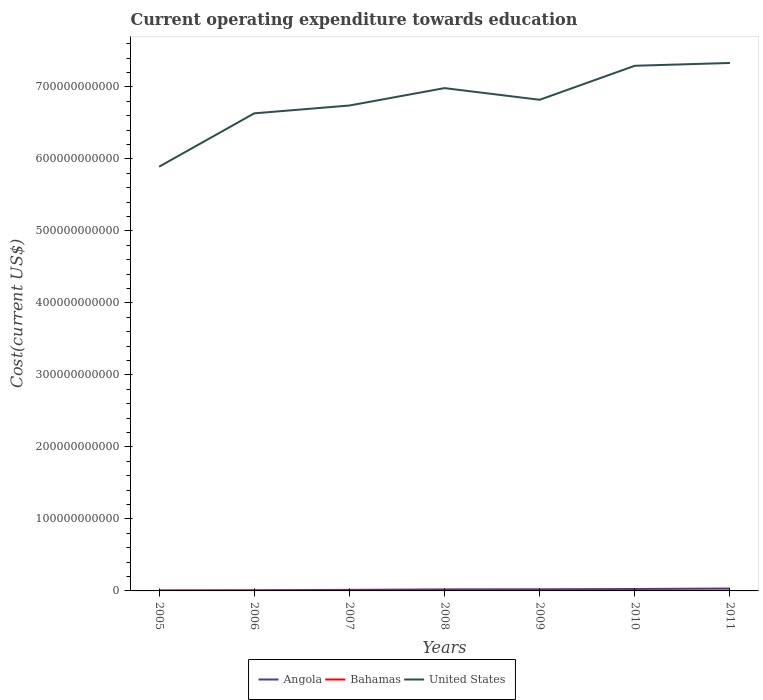How many different coloured lines are there?
Give a very brief answer. 3. Does the line corresponding to Angola intersect with the line corresponding to United States?
Provide a succinct answer. No. Is the number of lines equal to the number of legend labels?
Provide a succinct answer. Yes. Across all years, what is the maximum expenditure towards education in Angola?
Provide a short and direct response. 6.26e+08. What is the total expenditure towards education in United States in the graph?
Keep it short and to the point. -9.29e+1. What is the difference between the highest and the second highest expenditure towards education in United States?
Your response must be concise. 1.44e+11. Is the expenditure towards education in United States strictly greater than the expenditure towards education in Angola over the years?
Give a very brief answer. No. What is the difference between two consecutive major ticks on the Y-axis?
Ensure brevity in your answer.  1.00e+11. Are the values on the major ticks of Y-axis written in scientific E-notation?
Offer a terse response. No. Does the graph contain grids?
Make the answer very short. No. How many legend labels are there?
Give a very brief answer. 3. What is the title of the graph?
Offer a terse response. Current operating expenditure towards education. What is the label or title of the X-axis?
Your response must be concise. Years. What is the label or title of the Y-axis?
Your answer should be compact. Cost(current US$). What is the Cost(current US$) of Angola in 2005?
Keep it short and to the point. 6.26e+08. What is the Cost(current US$) in Bahamas in 2005?
Provide a succinct answer. 2.89e+08. What is the Cost(current US$) of United States in 2005?
Provide a succinct answer. 5.89e+11. What is the Cost(current US$) of Angola in 2006?
Keep it short and to the point. 8.86e+08. What is the Cost(current US$) in Bahamas in 2006?
Your answer should be compact. 2.97e+08. What is the Cost(current US$) in United States in 2006?
Offer a very short reply. 6.63e+11. What is the Cost(current US$) of Angola in 2007?
Your response must be concise. 1.46e+09. What is the Cost(current US$) in Bahamas in 2007?
Your response must be concise. 3.10e+08. What is the Cost(current US$) of United States in 2007?
Ensure brevity in your answer.  6.74e+11. What is the Cost(current US$) in Angola in 2008?
Keep it short and to the point. 2.14e+09. What is the Cost(current US$) in Bahamas in 2008?
Your answer should be compact. 3.13e+08. What is the Cost(current US$) of United States in 2008?
Your answer should be very brief. 6.98e+11. What is the Cost(current US$) in Angola in 2009?
Your response must be concise. 2.27e+09. What is the Cost(current US$) of Bahamas in 2009?
Give a very brief answer. 2.94e+08. What is the Cost(current US$) in United States in 2009?
Your response must be concise. 6.82e+11. What is the Cost(current US$) of Angola in 2010?
Your answer should be compact. 2.66e+09. What is the Cost(current US$) of Bahamas in 2010?
Offer a terse response. 2.94e+08. What is the Cost(current US$) of United States in 2010?
Your answer should be very brief. 7.29e+11. What is the Cost(current US$) of Angola in 2011?
Make the answer very short. 3.35e+09. What is the Cost(current US$) in Bahamas in 2011?
Keep it short and to the point. 2.94e+08. What is the Cost(current US$) in United States in 2011?
Offer a very short reply. 7.33e+11. Across all years, what is the maximum Cost(current US$) of Angola?
Provide a succinct answer. 3.35e+09. Across all years, what is the maximum Cost(current US$) in Bahamas?
Your response must be concise. 3.13e+08. Across all years, what is the maximum Cost(current US$) in United States?
Ensure brevity in your answer.  7.33e+11. Across all years, what is the minimum Cost(current US$) in Angola?
Provide a succinct answer. 6.26e+08. Across all years, what is the minimum Cost(current US$) in Bahamas?
Keep it short and to the point. 2.89e+08. Across all years, what is the minimum Cost(current US$) of United States?
Your answer should be very brief. 5.89e+11. What is the total Cost(current US$) in Angola in the graph?
Your response must be concise. 1.34e+1. What is the total Cost(current US$) of Bahamas in the graph?
Provide a succinct answer. 2.09e+09. What is the total Cost(current US$) of United States in the graph?
Your response must be concise. 4.77e+12. What is the difference between the Cost(current US$) of Angola in 2005 and that in 2006?
Keep it short and to the point. -2.60e+08. What is the difference between the Cost(current US$) in Bahamas in 2005 and that in 2006?
Provide a short and direct response. -8.57e+06. What is the difference between the Cost(current US$) of United States in 2005 and that in 2006?
Make the answer very short. -7.41e+1. What is the difference between the Cost(current US$) in Angola in 2005 and that in 2007?
Offer a terse response. -8.34e+08. What is the difference between the Cost(current US$) of Bahamas in 2005 and that in 2007?
Give a very brief answer. -2.16e+07. What is the difference between the Cost(current US$) of United States in 2005 and that in 2007?
Make the answer very short. -8.50e+1. What is the difference between the Cost(current US$) in Angola in 2005 and that in 2008?
Keep it short and to the point. -1.52e+09. What is the difference between the Cost(current US$) in Bahamas in 2005 and that in 2008?
Ensure brevity in your answer.  -2.44e+07. What is the difference between the Cost(current US$) in United States in 2005 and that in 2008?
Offer a terse response. -1.09e+11. What is the difference between the Cost(current US$) of Angola in 2005 and that in 2009?
Ensure brevity in your answer.  -1.65e+09. What is the difference between the Cost(current US$) in Bahamas in 2005 and that in 2009?
Keep it short and to the point. -5.53e+06. What is the difference between the Cost(current US$) in United States in 2005 and that in 2009?
Keep it short and to the point. -9.29e+1. What is the difference between the Cost(current US$) in Angola in 2005 and that in 2010?
Provide a succinct answer. -2.04e+09. What is the difference between the Cost(current US$) in Bahamas in 2005 and that in 2010?
Your answer should be very brief. -5.77e+06. What is the difference between the Cost(current US$) of United States in 2005 and that in 2010?
Ensure brevity in your answer.  -1.40e+11. What is the difference between the Cost(current US$) in Angola in 2005 and that in 2011?
Make the answer very short. -2.72e+09. What is the difference between the Cost(current US$) in Bahamas in 2005 and that in 2011?
Offer a terse response. -4.97e+06. What is the difference between the Cost(current US$) of United States in 2005 and that in 2011?
Keep it short and to the point. -1.44e+11. What is the difference between the Cost(current US$) in Angola in 2006 and that in 2007?
Offer a very short reply. -5.75e+08. What is the difference between the Cost(current US$) in Bahamas in 2006 and that in 2007?
Offer a terse response. -1.30e+07. What is the difference between the Cost(current US$) of United States in 2006 and that in 2007?
Offer a terse response. -1.09e+1. What is the difference between the Cost(current US$) of Angola in 2006 and that in 2008?
Make the answer very short. -1.26e+09. What is the difference between the Cost(current US$) of Bahamas in 2006 and that in 2008?
Offer a very short reply. -1.59e+07. What is the difference between the Cost(current US$) of United States in 2006 and that in 2008?
Your response must be concise. -3.50e+1. What is the difference between the Cost(current US$) in Angola in 2006 and that in 2009?
Provide a succinct answer. -1.39e+09. What is the difference between the Cost(current US$) of Bahamas in 2006 and that in 2009?
Offer a very short reply. 3.04e+06. What is the difference between the Cost(current US$) in United States in 2006 and that in 2009?
Provide a short and direct response. -1.88e+1. What is the difference between the Cost(current US$) in Angola in 2006 and that in 2010?
Ensure brevity in your answer.  -1.78e+09. What is the difference between the Cost(current US$) in Bahamas in 2006 and that in 2010?
Provide a short and direct response. 2.80e+06. What is the difference between the Cost(current US$) of United States in 2006 and that in 2010?
Your response must be concise. -6.61e+1. What is the difference between the Cost(current US$) of Angola in 2006 and that in 2011?
Your answer should be compact. -2.46e+09. What is the difference between the Cost(current US$) in Bahamas in 2006 and that in 2011?
Give a very brief answer. 3.60e+06. What is the difference between the Cost(current US$) of United States in 2006 and that in 2011?
Your answer should be very brief. -7.00e+1. What is the difference between the Cost(current US$) of Angola in 2007 and that in 2008?
Ensure brevity in your answer.  -6.82e+08. What is the difference between the Cost(current US$) of Bahamas in 2007 and that in 2008?
Make the answer very short. -2.84e+06. What is the difference between the Cost(current US$) of United States in 2007 and that in 2008?
Your answer should be very brief. -2.42e+1. What is the difference between the Cost(current US$) in Angola in 2007 and that in 2009?
Give a very brief answer. -8.11e+08. What is the difference between the Cost(current US$) in Bahamas in 2007 and that in 2009?
Your answer should be very brief. 1.61e+07. What is the difference between the Cost(current US$) in United States in 2007 and that in 2009?
Ensure brevity in your answer.  -7.97e+09. What is the difference between the Cost(current US$) of Angola in 2007 and that in 2010?
Your answer should be compact. -1.20e+09. What is the difference between the Cost(current US$) in Bahamas in 2007 and that in 2010?
Your answer should be very brief. 1.58e+07. What is the difference between the Cost(current US$) of United States in 2007 and that in 2010?
Your answer should be very brief. -5.52e+1. What is the difference between the Cost(current US$) in Angola in 2007 and that in 2011?
Provide a succinct answer. -1.89e+09. What is the difference between the Cost(current US$) of Bahamas in 2007 and that in 2011?
Ensure brevity in your answer.  1.66e+07. What is the difference between the Cost(current US$) in United States in 2007 and that in 2011?
Your answer should be very brief. -5.91e+1. What is the difference between the Cost(current US$) in Angola in 2008 and that in 2009?
Make the answer very short. -1.28e+08. What is the difference between the Cost(current US$) in Bahamas in 2008 and that in 2009?
Keep it short and to the point. 1.89e+07. What is the difference between the Cost(current US$) in United States in 2008 and that in 2009?
Offer a terse response. 1.62e+1. What is the difference between the Cost(current US$) of Angola in 2008 and that in 2010?
Offer a terse response. -5.19e+08. What is the difference between the Cost(current US$) in Bahamas in 2008 and that in 2010?
Provide a short and direct response. 1.87e+07. What is the difference between the Cost(current US$) of United States in 2008 and that in 2010?
Offer a terse response. -3.10e+1. What is the difference between the Cost(current US$) of Angola in 2008 and that in 2011?
Offer a terse response. -1.21e+09. What is the difference between the Cost(current US$) in Bahamas in 2008 and that in 2011?
Ensure brevity in your answer.  1.95e+07. What is the difference between the Cost(current US$) of United States in 2008 and that in 2011?
Ensure brevity in your answer.  -3.49e+1. What is the difference between the Cost(current US$) of Angola in 2009 and that in 2010?
Keep it short and to the point. -3.91e+08. What is the difference between the Cost(current US$) of Bahamas in 2009 and that in 2010?
Ensure brevity in your answer.  -2.47e+05. What is the difference between the Cost(current US$) in United States in 2009 and that in 2010?
Give a very brief answer. -4.72e+1. What is the difference between the Cost(current US$) in Angola in 2009 and that in 2011?
Offer a terse response. -1.08e+09. What is the difference between the Cost(current US$) of Bahamas in 2009 and that in 2011?
Offer a very short reply. 5.57e+05. What is the difference between the Cost(current US$) of United States in 2009 and that in 2011?
Provide a short and direct response. -5.11e+1. What is the difference between the Cost(current US$) in Angola in 2010 and that in 2011?
Give a very brief answer. -6.88e+08. What is the difference between the Cost(current US$) in Bahamas in 2010 and that in 2011?
Provide a short and direct response. 8.04e+05. What is the difference between the Cost(current US$) in United States in 2010 and that in 2011?
Offer a very short reply. -3.88e+09. What is the difference between the Cost(current US$) in Angola in 2005 and the Cost(current US$) in Bahamas in 2006?
Provide a short and direct response. 3.29e+08. What is the difference between the Cost(current US$) of Angola in 2005 and the Cost(current US$) of United States in 2006?
Ensure brevity in your answer.  -6.63e+11. What is the difference between the Cost(current US$) in Bahamas in 2005 and the Cost(current US$) in United States in 2006?
Offer a very short reply. -6.63e+11. What is the difference between the Cost(current US$) in Angola in 2005 and the Cost(current US$) in Bahamas in 2007?
Offer a terse response. 3.16e+08. What is the difference between the Cost(current US$) of Angola in 2005 and the Cost(current US$) of United States in 2007?
Offer a very short reply. -6.73e+11. What is the difference between the Cost(current US$) in Bahamas in 2005 and the Cost(current US$) in United States in 2007?
Your answer should be very brief. -6.74e+11. What is the difference between the Cost(current US$) of Angola in 2005 and the Cost(current US$) of Bahamas in 2008?
Ensure brevity in your answer.  3.13e+08. What is the difference between the Cost(current US$) in Angola in 2005 and the Cost(current US$) in United States in 2008?
Your answer should be compact. -6.98e+11. What is the difference between the Cost(current US$) of Bahamas in 2005 and the Cost(current US$) of United States in 2008?
Give a very brief answer. -6.98e+11. What is the difference between the Cost(current US$) in Angola in 2005 and the Cost(current US$) in Bahamas in 2009?
Make the answer very short. 3.32e+08. What is the difference between the Cost(current US$) in Angola in 2005 and the Cost(current US$) in United States in 2009?
Make the answer very short. -6.81e+11. What is the difference between the Cost(current US$) of Bahamas in 2005 and the Cost(current US$) of United States in 2009?
Give a very brief answer. -6.82e+11. What is the difference between the Cost(current US$) of Angola in 2005 and the Cost(current US$) of Bahamas in 2010?
Provide a succinct answer. 3.32e+08. What is the difference between the Cost(current US$) in Angola in 2005 and the Cost(current US$) in United States in 2010?
Provide a short and direct response. -7.29e+11. What is the difference between the Cost(current US$) in Bahamas in 2005 and the Cost(current US$) in United States in 2010?
Provide a short and direct response. -7.29e+11. What is the difference between the Cost(current US$) in Angola in 2005 and the Cost(current US$) in Bahamas in 2011?
Ensure brevity in your answer.  3.32e+08. What is the difference between the Cost(current US$) of Angola in 2005 and the Cost(current US$) of United States in 2011?
Your answer should be compact. -7.33e+11. What is the difference between the Cost(current US$) in Bahamas in 2005 and the Cost(current US$) in United States in 2011?
Your answer should be compact. -7.33e+11. What is the difference between the Cost(current US$) in Angola in 2006 and the Cost(current US$) in Bahamas in 2007?
Provide a short and direct response. 5.75e+08. What is the difference between the Cost(current US$) of Angola in 2006 and the Cost(current US$) of United States in 2007?
Give a very brief answer. -6.73e+11. What is the difference between the Cost(current US$) in Bahamas in 2006 and the Cost(current US$) in United States in 2007?
Keep it short and to the point. -6.74e+11. What is the difference between the Cost(current US$) in Angola in 2006 and the Cost(current US$) in Bahamas in 2008?
Your response must be concise. 5.73e+08. What is the difference between the Cost(current US$) in Angola in 2006 and the Cost(current US$) in United States in 2008?
Give a very brief answer. -6.97e+11. What is the difference between the Cost(current US$) in Bahamas in 2006 and the Cost(current US$) in United States in 2008?
Keep it short and to the point. -6.98e+11. What is the difference between the Cost(current US$) of Angola in 2006 and the Cost(current US$) of Bahamas in 2009?
Give a very brief answer. 5.91e+08. What is the difference between the Cost(current US$) of Angola in 2006 and the Cost(current US$) of United States in 2009?
Make the answer very short. -6.81e+11. What is the difference between the Cost(current US$) of Bahamas in 2006 and the Cost(current US$) of United States in 2009?
Your response must be concise. -6.82e+11. What is the difference between the Cost(current US$) in Angola in 2006 and the Cost(current US$) in Bahamas in 2010?
Offer a very short reply. 5.91e+08. What is the difference between the Cost(current US$) of Angola in 2006 and the Cost(current US$) of United States in 2010?
Make the answer very short. -7.28e+11. What is the difference between the Cost(current US$) in Bahamas in 2006 and the Cost(current US$) in United States in 2010?
Offer a very short reply. -7.29e+11. What is the difference between the Cost(current US$) of Angola in 2006 and the Cost(current US$) of Bahamas in 2011?
Ensure brevity in your answer.  5.92e+08. What is the difference between the Cost(current US$) in Angola in 2006 and the Cost(current US$) in United States in 2011?
Make the answer very short. -7.32e+11. What is the difference between the Cost(current US$) of Bahamas in 2006 and the Cost(current US$) of United States in 2011?
Your answer should be compact. -7.33e+11. What is the difference between the Cost(current US$) in Angola in 2007 and the Cost(current US$) in Bahamas in 2008?
Provide a short and direct response. 1.15e+09. What is the difference between the Cost(current US$) of Angola in 2007 and the Cost(current US$) of United States in 2008?
Provide a succinct answer. -6.97e+11. What is the difference between the Cost(current US$) of Bahamas in 2007 and the Cost(current US$) of United States in 2008?
Give a very brief answer. -6.98e+11. What is the difference between the Cost(current US$) in Angola in 2007 and the Cost(current US$) in Bahamas in 2009?
Make the answer very short. 1.17e+09. What is the difference between the Cost(current US$) of Angola in 2007 and the Cost(current US$) of United States in 2009?
Make the answer very short. -6.81e+11. What is the difference between the Cost(current US$) of Bahamas in 2007 and the Cost(current US$) of United States in 2009?
Make the answer very short. -6.82e+11. What is the difference between the Cost(current US$) in Angola in 2007 and the Cost(current US$) in Bahamas in 2010?
Offer a very short reply. 1.17e+09. What is the difference between the Cost(current US$) in Angola in 2007 and the Cost(current US$) in United States in 2010?
Give a very brief answer. -7.28e+11. What is the difference between the Cost(current US$) of Bahamas in 2007 and the Cost(current US$) of United States in 2010?
Give a very brief answer. -7.29e+11. What is the difference between the Cost(current US$) of Angola in 2007 and the Cost(current US$) of Bahamas in 2011?
Make the answer very short. 1.17e+09. What is the difference between the Cost(current US$) in Angola in 2007 and the Cost(current US$) in United States in 2011?
Provide a succinct answer. -7.32e+11. What is the difference between the Cost(current US$) of Bahamas in 2007 and the Cost(current US$) of United States in 2011?
Provide a short and direct response. -7.33e+11. What is the difference between the Cost(current US$) of Angola in 2008 and the Cost(current US$) of Bahamas in 2009?
Make the answer very short. 1.85e+09. What is the difference between the Cost(current US$) of Angola in 2008 and the Cost(current US$) of United States in 2009?
Make the answer very short. -6.80e+11. What is the difference between the Cost(current US$) in Bahamas in 2008 and the Cost(current US$) in United States in 2009?
Ensure brevity in your answer.  -6.82e+11. What is the difference between the Cost(current US$) of Angola in 2008 and the Cost(current US$) of Bahamas in 2010?
Provide a short and direct response. 1.85e+09. What is the difference between the Cost(current US$) in Angola in 2008 and the Cost(current US$) in United States in 2010?
Your answer should be compact. -7.27e+11. What is the difference between the Cost(current US$) of Bahamas in 2008 and the Cost(current US$) of United States in 2010?
Your response must be concise. -7.29e+11. What is the difference between the Cost(current US$) in Angola in 2008 and the Cost(current US$) in Bahamas in 2011?
Provide a succinct answer. 1.85e+09. What is the difference between the Cost(current US$) of Angola in 2008 and the Cost(current US$) of United States in 2011?
Your response must be concise. -7.31e+11. What is the difference between the Cost(current US$) in Bahamas in 2008 and the Cost(current US$) in United States in 2011?
Ensure brevity in your answer.  -7.33e+11. What is the difference between the Cost(current US$) of Angola in 2009 and the Cost(current US$) of Bahamas in 2010?
Offer a terse response. 1.98e+09. What is the difference between the Cost(current US$) in Angola in 2009 and the Cost(current US$) in United States in 2010?
Provide a succinct answer. -7.27e+11. What is the difference between the Cost(current US$) in Bahamas in 2009 and the Cost(current US$) in United States in 2010?
Your response must be concise. -7.29e+11. What is the difference between the Cost(current US$) of Angola in 2009 and the Cost(current US$) of Bahamas in 2011?
Give a very brief answer. 1.98e+09. What is the difference between the Cost(current US$) of Angola in 2009 and the Cost(current US$) of United States in 2011?
Make the answer very short. -7.31e+11. What is the difference between the Cost(current US$) of Bahamas in 2009 and the Cost(current US$) of United States in 2011?
Keep it short and to the point. -7.33e+11. What is the difference between the Cost(current US$) of Angola in 2010 and the Cost(current US$) of Bahamas in 2011?
Your response must be concise. 2.37e+09. What is the difference between the Cost(current US$) in Angola in 2010 and the Cost(current US$) in United States in 2011?
Ensure brevity in your answer.  -7.31e+11. What is the difference between the Cost(current US$) in Bahamas in 2010 and the Cost(current US$) in United States in 2011?
Provide a succinct answer. -7.33e+11. What is the average Cost(current US$) in Angola per year?
Your answer should be compact. 1.91e+09. What is the average Cost(current US$) of Bahamas per year?
Your answer should be very brief. 2.99e+08. What is the average Cost(current US$) of United States per year?
Your answer should be very brief. 6.81e+11. In the year 2005, what is the difference between the Cost(current US$) in Angola and Cost(current US$) in Bahamas?
Ensure brevity in your answer.  3.37e+08. In the year 2005, what is the difference between the Cost(current US$) in Angola and Cost(current US$) in United States?
Your answer should be compact. -5.88e+11. In the year 2005, what is the difference between the Cost(current US$) of Bahamas and Cost(current US$) of United States?
Give a very brief answer. -5.89e+11. In the year 2006, what is the difference between the Cost(current US$) in Angola and Cost(current US$) in Bahamas?
Give a very brief answer. 5.88e+08. In the year 2006, what is the difference between the Cost(current US$) of Angola and Cost(current US$) of United States?
Offer a terse response. -6.62e+11. In the year 2006, what is the difference between the Cost(current US$) in Bahamas and Cost(current US$) in United States?
Your answer should be very brief. -6.63e+11. In the year 2007, what is the difference between the Cost(current US$) of Angola and Cost(current US$) of Bahamas?
Provide a succinct answer. 1.15e+09. In the year 2007, what is the difference between the Cost(current US$) of Angola and Cost(current US$) of United States?
Make the answer very short. -6.73e+11. In the year 2007, what is the difference between the Cost(current US$) in Bahamas and Cost(current US$) in United States?
Offer a terse response. -6.74e+11. In the year 2008, what is the difference between the Cost(current US$) in Angola and Cost(current US$) in Bahamas?
Offer a very short reply. 1.83e+09. In the year 2008, what is the difference between the Cost(current US$) of Angola and Cost(current US$) of United States?
Offer a terse response. -6.96e+11. In the year 2008, what is the difference between the Cost(current US$) of Bahamas and Cost(current US$) of United States?
Keep it short and to the point. -6.98e+11. In the year 2009, what is the difference between the Cost(current US$) of Angola and Cost(current US$) of Bahamas?
Give a very brief answer. 1.98e+09. In the year 2009, what is the difference between the Cost(current US$) of Angola and Cost(current US$) of United States?
Your answer should be compact. -6.80e+11. In the year 2009, what is the difference between the Cost(current US$) of Bahamas and Cost(current US$) of United States?
Your answer should be compact. -6.82e+11. In the year 2010, what is the difference between the Cost(current US$) in Angola and Cost(current US$) in Bahamas?
Offer a terse response. 2.37e+09. In the year 2010, what is the difference between the Cost(current US$) of Angola and Cost(current US$) of United States?
Ensure brevity in your answer.  -7.27e+11. In the year 2010, what is the difference between the Cost(current US$) in Bahamas and Cost(current US$) in United States?
Make the answer very short. -7.29e+11. In the year 2011, what is the difference between the Cost(current US$) of Angola and Cost(current US$) of Bahamas?
Keep it short and to the point. 3.06e+09. In the year 2011, what is the difference between the Cost(current US$) of Angola and Cost(current US$) of United States?
Provide a short and direct response. -7.30e+11. In the year 2011, what is the difference between the Cost(current US$) in Bahamas and Cost(current US$) in United States?
Ensure brevity in your answer.  -7.33e+11. What is the ratio of the Cost(current US$) of Angola in 2005 to that in 2006?
Your answer should be very brief. 0.71. What is the ratio of the Cost(current US$) of Bahamas in 2005 to that in 2006?
Offer a very short reply. 0.97. What is the ratio of the Cost(current US$) of United States in 2005 to that in 2006?
Provide a short and direct response. 0.89. What is the ratio of the Cost(current US$) of Angola in 2005 to that in 2007?
Give a very brief answer. 0.43. What is the ratio of the Cost(current US$) of Bahamas in 2005 to that in 2007?
Ensure brevity in your answer.  0.93. What is the ratio of the Cost(current US$) in United States in 2005 to that in 2007?
Your answer should be very brief. 0.87. What is the ratio of the Cost(current US$) of Angola in 2005 to that in 2008?
Make the answer very short. 0.29. What is the ratio of the Cost(current US$) in Bahamas in 2005 to that in 2008?
Your answer should be compact. 0.92. What is the ratio of the Cost(current US$) in United States in 2005 to that in 2008?
Keep it short and to the point. 0.84. What is the ratio of the Cost(current US$) of Angola in 2005 to that in 2009?
Provide a succinct answer. 0.28. What is the ratio of the Cost(current US$) of Bahamas in 2005 to that in 2009?
Your answer should be very brief. 0.98. What is the ratio of the Cost(current US$) of United States in 2005 to that in 2009?
Your answer should be compact. 0.86. What is the ratio of the Cost(current US$) of Angola in 2005 to that in 2010?
Your answer should be very brief. 0.24. What is the ratio of the Cost(current US$) of Bahamas in 2005 to that in 2010?
Ensure brevity in your answer.  0.98. What is the ratio of the Cost(current US$) of United States in 2005 to that in 2010?
Your answer should be very brief. 0.81. What is the ratio of the Cost(current US$) of Angola in 2005 to that in 2011?
Ensure brevity in your answer.  0.19. What is the ratio of the Cost(current US$) of Bahamas in 2005 to that in 2011?
Keep it short and to the point. 0.98. What is the ratio of the Cost(current US$) in United States in 2005 to that in 2011?
Keep it short and to the point. 0.8. What is the ratio of the Cost(current US$) in Angola in 2006 to that in 2007?
Offer a very short reply. 0.61. What is the ratio of the Cost(current US$) in Bahamas in 2006 to that in 2007?
Offer a very short reply. 0.96. What is the ratio of the Cost(current US$) in United States in 2006 to that in 2007?
Your answer should be very brief. 0.98. What is the ratio of the Cost(current US$) in Angola in 2006 to that in 2008?
Offer a very short reply. 0.41. What is the ratio of the Cost(current US$) of Bahamas in 2006 to that in 2008?
Your answer should be very brief. 0.95. What is the ratio of the Cost(current US$) of United States in 2006 to that in 2008?
Offer a terse response. 0.95. What is the ratio of the Cost(current US$) of Angola in 2006 to that in 2009?
Provide a short and direct response. 0.39. What is the ratio of the Cost(current US$) in Bahamas in 2006 to that in 2009?
Provide a succinct answer. 1.01. What is the ratio of the Cost(current US$) in United States in 2006 to that in 2009?
Give a very brief answer. 0.97. What is the ratio of the Cost(current US$) of Angola in 2006 to that in 2010?
Make the answer very short. 0.33. What is the ratio of the Cost(current US$) of Bahamas in 2006 to that in 2010?
Provide a succinct answer. 1.01. What is the ratio of the Cost(current US$) of United States in 2006 to that in 2010?
Your response must be concise. 0.91. What is the ratio of the Cost(current US$) in Angola in 2006 to that in 2011?
Provide a succinct answer. 0.26. What is the ratio of the Cost(current US$) in Bahamas in 2006 to that in 2011?
Your answer should be very brief. 1.01. What is the ratio of the Cost(current US$) of United States in 2006 to that in 2011?
Keep it short and to the point. 0.9. What is the ratio of the Cost(current US$) of Angola in 2007 to that in 2008?
Offer a very short reply. 0.68. What is the ratio of the Cost(current US$) of Bahamas in 2007 to that in 2008?
Offer a very short reply. 0.99. What is the ratio of the Cost(current US$) of United States in 2007 to that in 2008?
Give a very brief answer. 0.97. What is the ratio of the Cost(current US$) of Angola in 2007 to that in 2009?
Ensure brevity in your answer.  0.64. What is the ratio of the Cost(current US$) of Bahamas in 2007 to that in 2009?
Your answer should be compact. 1.05. What is the ratio of the Cost(current US$) in United States in 2007 to that in 2009?
Your response must be concise. 0.99. What is the ratio of the Cost(current US$) in Angola in 2007 to that in 2010?
Your response must be concise. 0.55. What is the ratio of the Cost(current US$) in Bahamas in 2007 to that in 2010?
Your answer should be very brief. 1.05. What is the ratio of the Cost(current US$) of United States in 2007 to that in 2010?
Your answer should be compact. 0.92. What is the ratio of the Cost(current US$) of Angola in 2007 to that in 2011?
Your answer should be compact. 0.44. What is the ratio of the Cost(current US$) in Bahamas in 2007 to that in 2011?
Ensure brevity in your answer.  1.06. What is the ratio of the Cost(current US$) of United States in 2007 to that in 2011?
Offer a terse response. 0.92. What is the ratio of the Cost(current US$) in Angola in 2008 to that in 2009?
Ensure brevity in your answer.  0.94. What is the ratio of the Cost(current US$) of Bahamas in 2008 to that in 2009?
Keep it short and to the point. 1.06. What is the ratio of the Cost(current US$) in United States in 2008 to that in 2009?
Offer a very short reply. 1.02. What is the ratio of the Cost(current US$) in Angola in 2008 to that in 2010?
Offer a very short reply. 0.8. What is the ratio of the Cost(current US$) in Bahamas in 2008 to that in 2010?
Your answer should be very brief. 1.06. What is the ratio of the Cost(current US$) of United States in 2008 to that in 2010?
Give a very brief answer. 0.96. What is the ratio of the Cost(current US$) of Angola in 2008 to that in 2011?
Your answer should be compact. 0.64. What is the ratio of the Cost(current US$) of Bahamas in 2008 to that in 2011?
Offer a terse response. 1.07. What is the ratio of the Cost(current US$) in Angola in 2009 to that in 2010?
Provide a short and direct response. 0.85. What is the ratio of the Cost(current US$) of United States in 2009 to that in 2010?
Provide a short and direct response. 0.94. What is the ratio of the Cost(current US$) in Angola in 2009 to that in 2011?
Provide a succinct answer. 0.68. What is the ratio of the Cost(current US$) in Bahamas in 2009 to that in 2011?
Provide a succinct answer. 1. What is the ratio of the Cost(current US$) in United States in 2009 to that in 2011?
Your answer should be very brief. 0.93. What is the ratio of the Cost(current US$) of Angola in 2010 to that in 2011?
Your answer should be very brief. 0.79. What is the ratio of the Cost(current US$) in Bahamas in 2010 to that in 2011?
Offer a very short reply. 1. What is the ratio of the Cost(current US$) of United States in 2010 to that in 2011?
Provide a succinct answer. 0.99. What is the difference between the highest and the second highest Cost(current US$) of Angola?
Provide a short and direct response. 6.88e+08. What is the difference between the highest and the second highest Cost(current US$) of Bahamas?
Make the answer very short. 2.84e+06. What is the difference between the highest and the second highest Cost(current US$) in United States?
Your answer should be very brief. 3.88e+09. What is the difference between the highest and the lowest Cost(current US$) in Angola?
Offer a terse response. 2.72e+09. What is the difference between the highest and the lowest Cost(current US$) of Bahamas?
Offer a very short reply. 2.44e+07. What is the difference between the highest and the lowest Cost(current US$) in United States?
Offer a terse response. 1.44e+11. 